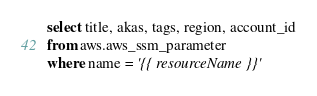<code> <loc_0><loc_0><loc_500><loc_500><_SQL_>select title, akas, tags, region, account_id
from aws.aws_ssm_parameter
where name = '{{ resourceName }}'
</code> 